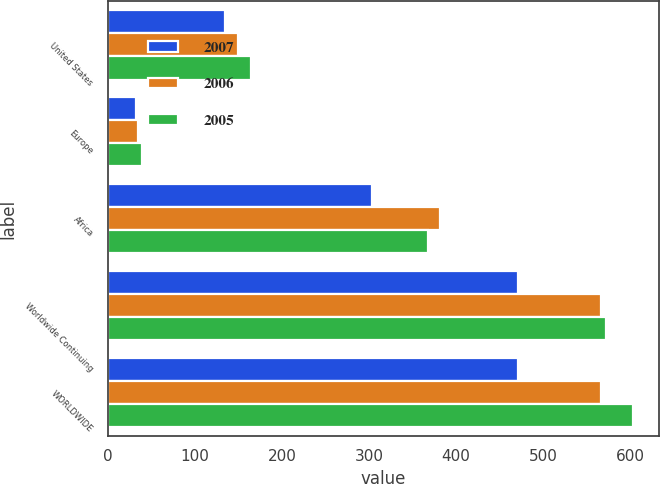Convert chart. <chart><loc_0><loc_0><loc_500><loc_500><stacked_bar_chart><ecel><fcel>United States<fcel>Europe<fcel>Africa<fcel>Worldwide Continuing<fcel>WORLDWIDE<nl><fcel>2007<fcel>135<fcel>32<fcel>304<fcel>471<fcel>471<nl><fcel>2006<fcel>150<fcel>35<fcel>381<fcel>566<fcel>566<nl><fcel>2005<fcel>165<fcel>39<fcel>368<fcel>572<fcel>603<nl></chart> 